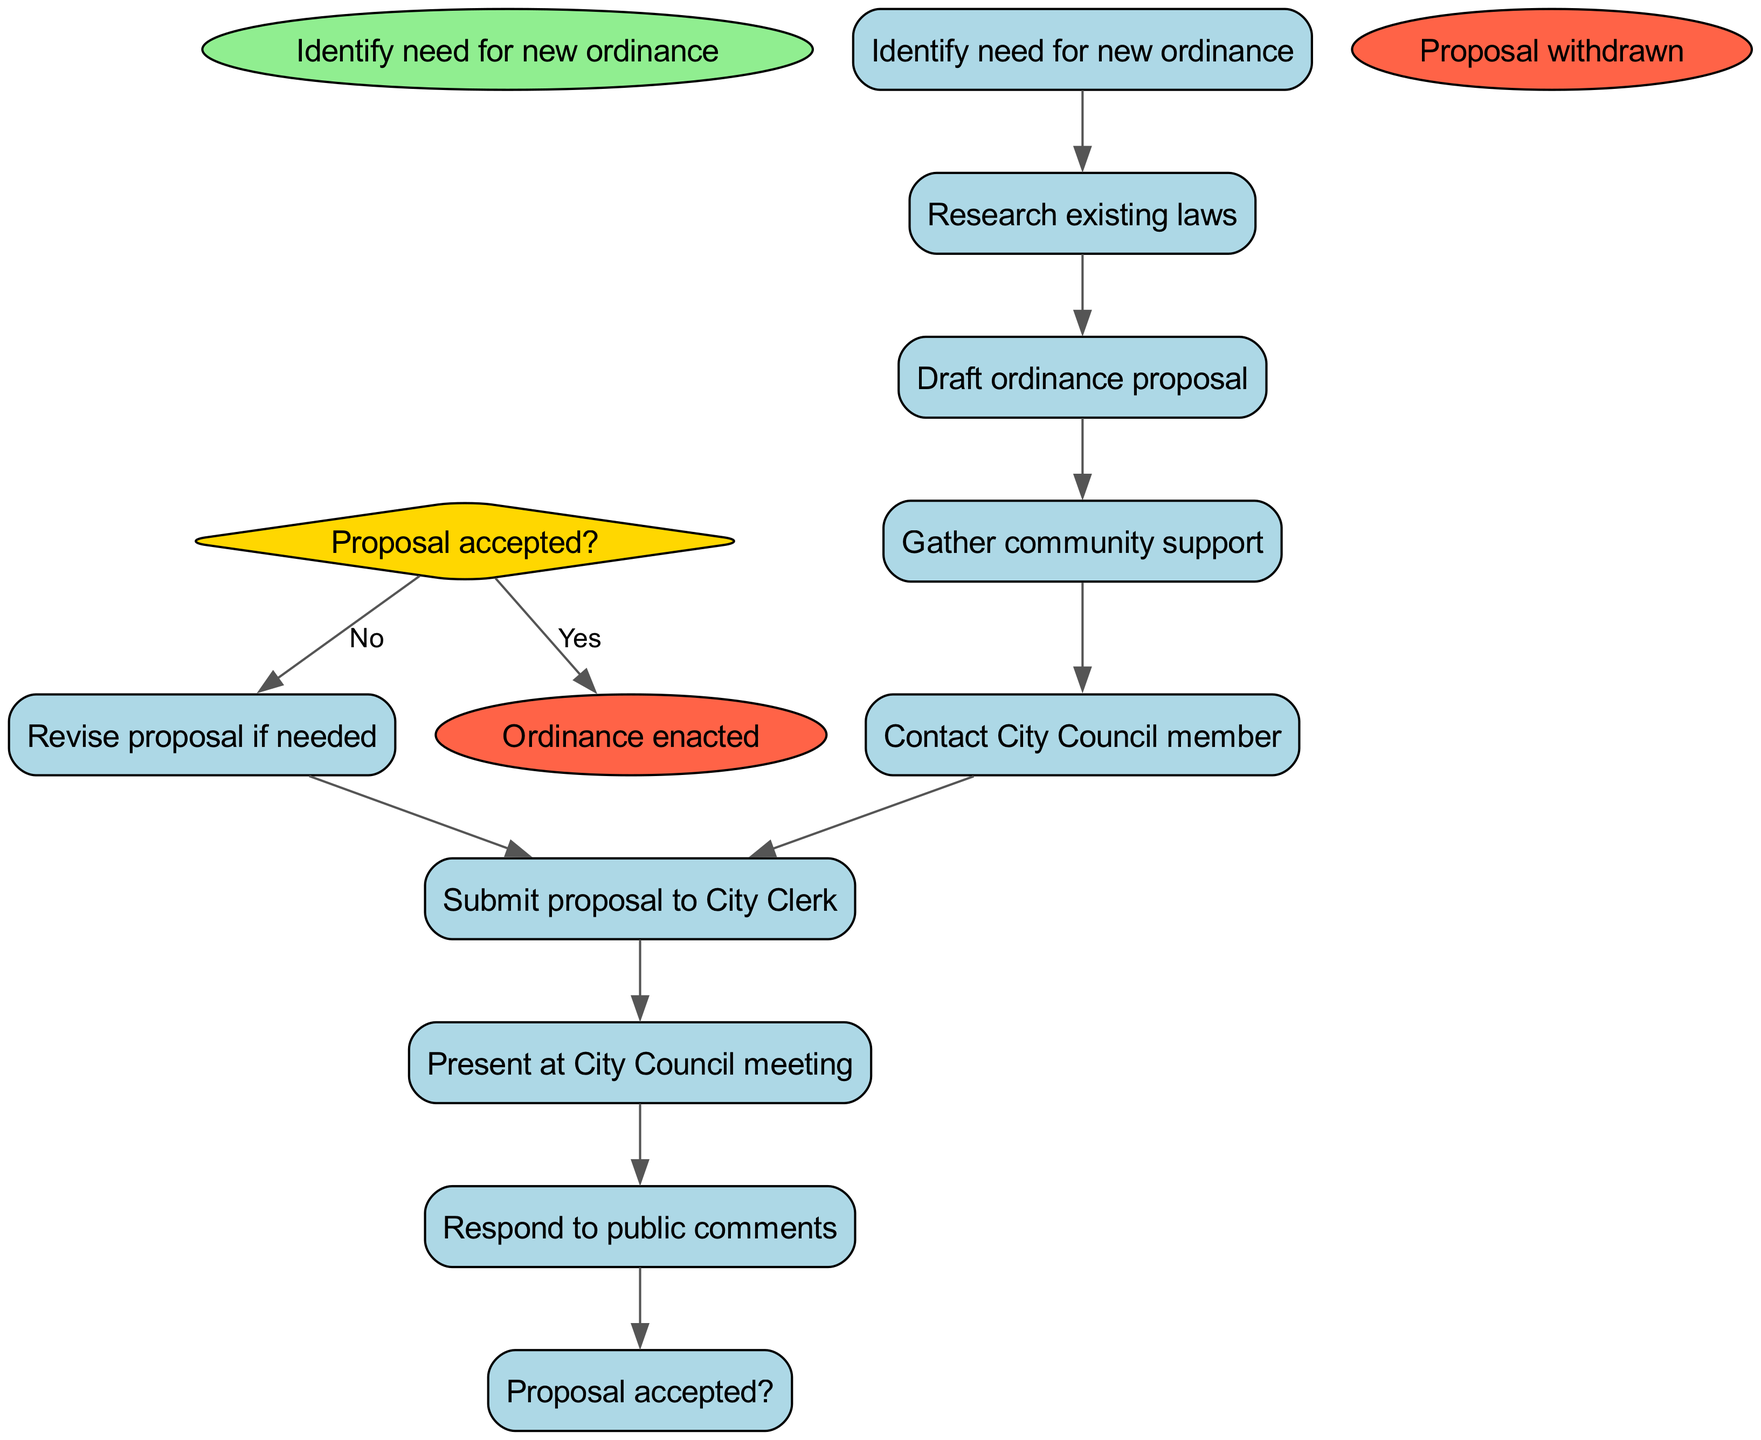What is the starting point of the activity diagram? The starting point of the activity diagram is labeled as "Identify need for new ordinance," which signifies the initiation of the process to propose a new ordinance.
Answer: Identify need for new ordinance How many activities are listed in the diagram? The diagram includes a total of eight activities that outline the steps involved in proposing a new ordinance. Counting the activities in the activities list confirms this number.
Answer: Eight What follows after gathering community support? According to the diagram, after "Gather community support," the next step is "Contact City Council member." This indicates the sequence of actions to be taken.
Answer: Contact City Council member What happens if the proposal is not accepted? If the proposal is not accepted, the diagram indicates that the next action is to "Revise proposal if needed," highlighting the requirement for adjustments before resubmission.
Answer: Revise proposal if needed What are the end results of the process? The diagram presents two possible end results: "Ordinance enacted" and "Proposal withdrawn." These signify the final outcomes depending on the progression of the proposal.
Answer: Ordinance enacted, Proposal withdrawn Which activity directly leads to the decision node? The activity immediately preceding the decision node is "Respond to public comments," as this step is where feedback is gathered to assess the proposal's acceptance.
Answer: Respond to public comments What is the decision made after responding to public comments? After "Respond to public comments," the decision made is simply whether the "Proposal accepted?" This indicates if the proposal can proceed or needs revision.
Answer: Proposal accepted? What action occurs before presenting at the City Council meeting? Before the presentation at the City Council meeting, the corresponding preceding action is "Submit proposal to City Clerk," which is necessary to officially introduce the proposal.
Answer: Submit proposal to City Clerk 